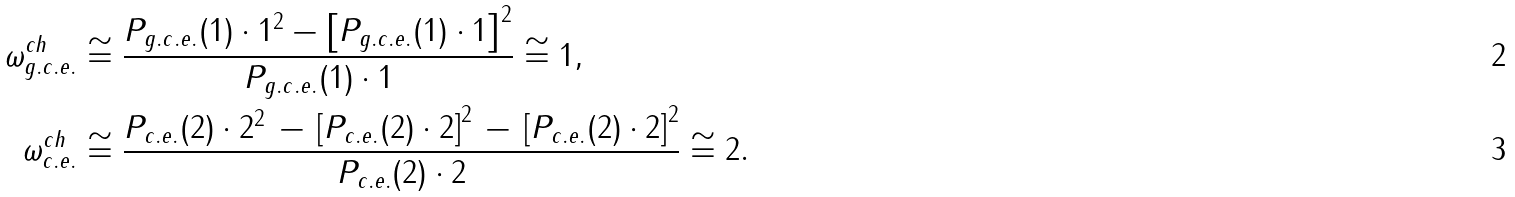Convert formula to latex. <formula><loc_0><loc_0><loc_500><loc_500>\omega ^ { c h } _ { g . c . e . } & \cong \frac { P _ { g . c . e . } ( 1 ) \cdot 1 ^ { 2 } - \left [ P _ { g . c . e . } ( 1 ) \cdot 1 \right ] ^ { 2 } } { P _ { g . c . e . } ( 1 ) \cdot 1 } \cong 1 , \\ \omega ^ { c h } _ { c . e . } & \cong \frac { P _ { c . e . } ( 2 ) \cdot 2 ^ { 2 } \, - \, \left [ P _ { c . e . } ( 2 ) \cdot 2 \right ] ^ { 2 } \, - \, \left [ P _ { c . e . } ( 2 ) \cdot 2 \right ] ^ { 2 } } { P _ { c . e . } ( 2 ) \cdot 2 } \cong 2 .</formula> 